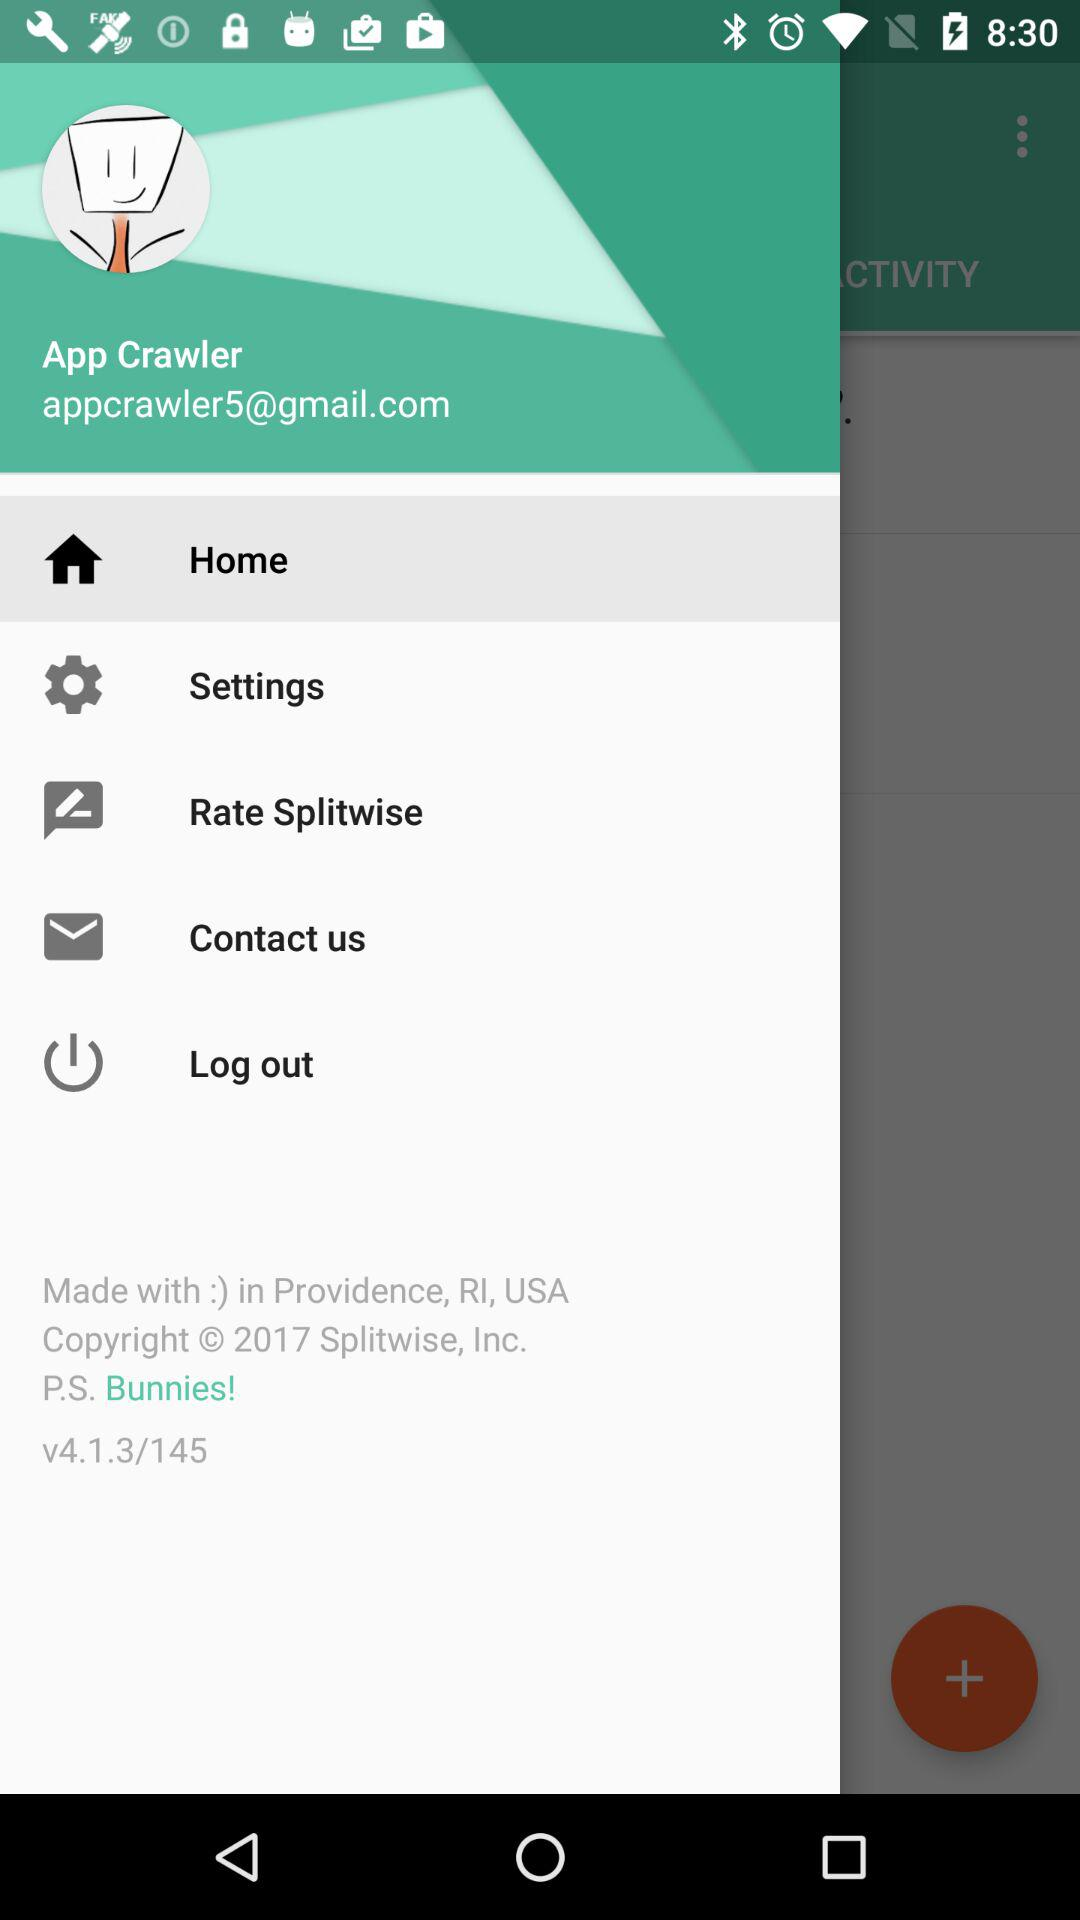What is the user name? The user name is App Crawler. 